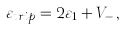<formula> <loc_0><loc_0><loc_500><loc_500>\varepsilon _ { t r i p } = 2 \varepsilon _ { 1 } + V _ { - } \, ,</formula> 